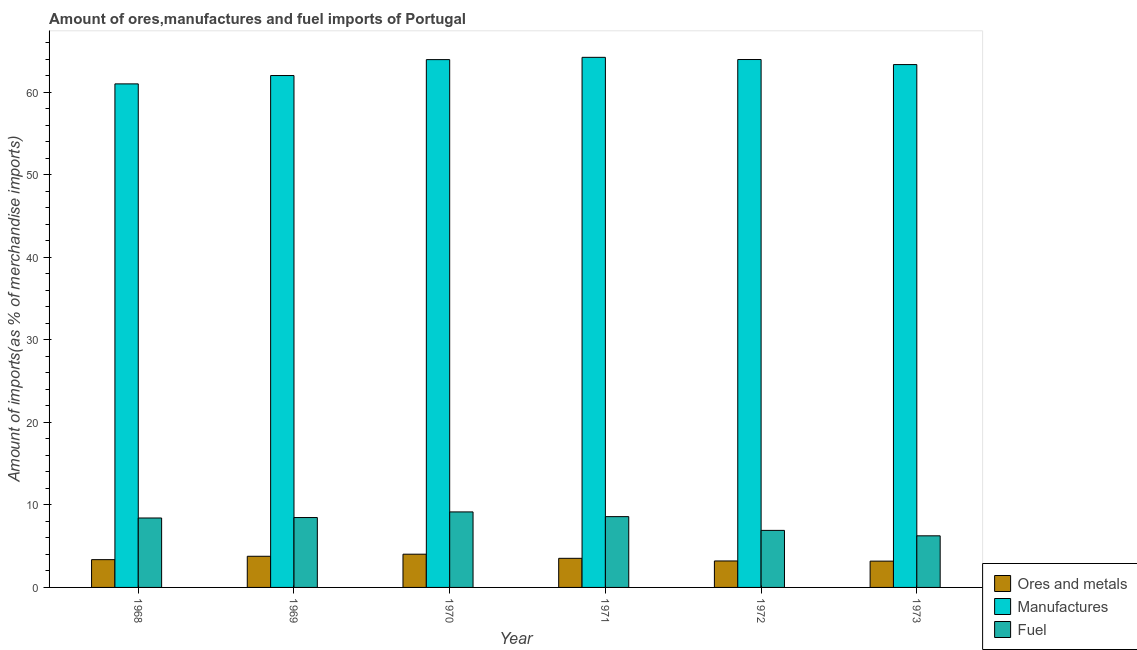How many different coloured bars are there?
Your response must be concise. 3. Are the number of bars on each tick of the X-axis equal?
Your answer should be very brief. Yes. How many bars are there on the 5th tick from the left?
Your response must be concise. 3. What is the label of the 6th group of bars from the left?
Make the answer very short. 1973. What is the percentage of fuel imports in 1970?
Keep it short and to the point. 9.15. Across all years, what is the maximum percentage of fuel imports?
Provide a succinct answer. 9.15. Across all years, what is the minimum percentage of ores and metals imports?
Your answer should be very brief. 3.18. In which year was the percentage of ores and metals imports minimum?
Offer a terse response. 1973. What is the total percentage of manufactures imports in the graph?
Offer a terse response. 378.41. What is the difference between the percentage of fuel imports in 1968 and that in 1972?
Your answer should be very brief. 1.5. What is the difference between the percentage of ores and metals imports in 1969 and the percentage of fuel imports in 1971?
Your response must be concise. 0.25. What is the average percentage of fuel imports per year?
Your response must be concise. 7.96. What is the ratio of the percentage of fuel imports in 1970 to that in 1971?
Your answer should be compact. 1.07. Is the percentage of fuel imports in 1969 less than that in 1971?
Make the answer very short. Yes. Is the difference between the percentage of manufactures imports in 1970 and 1971 greater than the difference between the percentage of ores and metals imports in 1970 and 1971?
Provide a short and direct response. No. What is the difference between the highest and the second highest percentage of ores and metals imports?
Ensure brevity in your answer.  0.25. What is the difference between the highest and the lowest percentage of fuel imports?
Your answer should be compact. 2.9. In how many years, is the percentage of ores and metals imports greater than the average percentage of ores and metals imports taken over all years?
Your answer should be compact. 3. What does the 1st bar from the left in 1969 represents?
Your answer should be compact. Ores and metals. What does the 1st bar from the right in 1971 represents?
Keep it short and to the point. Fuel. How many bars are there?
Provide a short and direct response. 18. Are all the bars in the graph horizontal?
Keep it short and to the point. No. How many years are there in the graph?
Ensure brevity in your answer.  6. What is the difference between two consecutive major ticks on the Y-axis?
Provide a short and direct response. 10. Are the values on the major ticks of Y-axis written in scientific E-notation?
Give a very brief answer. No. Where does the legend appear in the graph?
Offer a very short reply. Bottom right. How are the legend labels stacked?
Offer a terse response. Vertical. What is the title of the graph?
Ensure brevity in your answer.  Amount of ores,manufactures and fuel imports of Portugal. What is the label or title of the X-axis?
Give a very brief answer. Year. What is the label or title of the Y-axis?
Keep it short and to the point. Amount of imports(as % of merchandise imports). What is the Amount of imports(as % of merchandise imports) of Ores and metals in 1968?
Your answer should be compact. 3.37. What is the Amount of imports(as % of merchandise imports) of Manufactures in 1968?
Offer a very short reply. 60.99. What is the Amount of imports(as % of merchandise imports) in Fuel in 1968?
Keep it short and to the point. 8.41. What is the Amount of imports(as % of merchandise imports) in Ores and metals in 1969?
Ensure brevity in your answer.  3.77. What is the Amount of imports(as % of merchandise imports) in Manufactures in 1969?
Offer a very short reply. 62. What is the Amount of imports(as % of merchandise imports) in Fuel in 1969?
Your answer should be compact. 8.47. What is the Amount of imports(as % of merchandise imports) in Ores and metals in 1970?
Offer a terse response. 4.02. What is the Amount of imports(as % of merchandise imports) of Manufactures in 1970?
Offer a terse response. 63.93. What is the Amount of imports(as % of merchandise imports) of Fuel in 1970?
Your answer should be very brief. 9.15. What is the Amount of imports(as % of merchandise imports) of Ores and metals in 1971?
Keep it short and to the point. 3.53. What is the Amount of imports(as % of merchandise imports) of Manufactures in 1971?
Your answer should be compact. 64.21. What is the Amount of imports(as % of merchandise imports) in Fuel in 1971?
Make the answer very short. 8.57. What is the Amount of imports(as % of merchandise imports) of Ores and metals in 1972?
Give a very brief answer. 3.21. What is the Amount of imports(as % of merchandise imports) in Manufactures in 1972?
Provide a succinct answer. 63.94. What is the Amount of imports(as % of merchandise imports) in Fuel in 1972?
Your answer should be very brief. 6.91. What is the Amount of imports(as % of merchandise imports) in Ores and metals in 1973?
Keep it short and to the point. 3.18. What is the Amount of imports(as % of merchandise imports) of Manufactures in 1973?
Offer a terse response. 63.33. What is the Amount of imports(as % of merchandise imports) of Fuel in 1973?
Offer a terse response. 6.25. Across all years, what is the maximum Amount of imports(as % of merchandise imports) of Ores and metals?
Offer a very short reply. 4.02. Across all years, what is the maximum Amount of imports(as % of merchandise imports) in Manufactures?
Make the answer very short. 64.21. Across all years, what is the maximum Amount of imports(as % of merchandise imports) in Fuel?
Your answer should be compact. 9.15. Across all years, what is the minimum Amount of imports(as % of merchandise imports) of Ores and metals?
Make the answer very short. 3.18. Across all years, what is the minimum Amount of imports(as % of merchandise imports) of Manufactures?
Ensure brevity in your answer.  60.99. Across all years, what is the minimum Amount of imports(as % of merchandise imports) in Fuel?
Provide a short and direct response. 6.25. What is the total Amount of imports(as % of merchandise imports) in Ores and metals in the graph?
Offer a terse response. 21.08. What is the total Amount of imports(as % of merchandise imports) in Manufactures in the graph?
Give a very brief answer. 378.41. What is the total Amount of imports(as % of merchandise imports) in Fuel in the graph?
Make the answer very short. 47.76. What is the difference between the Amount of imports(as % of merchandise imports) in Ores and metals in 1968 and that in 1969?
Your answer should be compact. -0.41. What is the difference between the Amount of imports(as % of merchandise imports) of Manufactures in 1968 and that in 1969?
Provide a succinct answer. -1.01. What is the difference between the Amount of imports(as % of merchandise imports) of Fuel in 1968 and that in 1969?
Make the answer very short. -0.06. What is the difference between the Amount of imports(as % of merchandise imports) in Ores and metals in 1968 and that in 1970?
Give a very brief answer. -0.66. What is the difference between the Amount of imports(as % of merchandise imports) of Manufactures in 1968 and that in 1970?
Your answer should be compact. -2.94. What is the difference between the Amount of imports(as % of merchandise imports) of Fuel in 1968 and that in 1970?
Provide a succinct answer. -0.74. What is the difference between the Amount of imports(as % of merchandise imports) of Ores and metals in 1968 and that in 1971?
Your answer should be compact. -0.16. What is the difference between the Amount of imports(as % of merchandise imports) of Manufactures in 1968 and that in 1971?
Your answer should be very brief. -3.22. What is the difference between the Amount of imports(as % of merchandise imports) in Fuel in 1968 and that in 1971?
Ensure brevity in your answer.  -0.17. What is the difference between the Amount of imports(as % of merchandise imports) of Ores and metals in 1968 and that in 1972?
Give a very brief answer. 0.16. What is the difference between the Amount of imports(as % of merchandise imports) of Manufactures in 1968 and that in 1972?
Keep it short and to the point. -2.95. What is the difference between the Amount of imports(as % of merchandise imports) of Fuel in 1968 and that in 1972?
Provide a short and direct response. 1.5. What is the difference between the Amount of imports(as % of merchandise imports) in Ores and metals in 1968 and that in 1973?
Keep it short and to the point. 0.18. What is the difference between the Amount of imports(as % of merchandise imports) in Manufactures in 1968 and that in 1973?
Provide a succinct answer. -2.34. What is the difference between the Amount of imports(as % of merchandise imports) of Fuel in 1968 and that in 1973?
Offer a very short reply. 2.16. What is the difference between the Amount of imports(as % of merchandise imports) in Ores and metals in 1969 and that in 1970?
Offer a terse response. -0.25. What is the difference between the Amount of imports(as % of merchandise imports) of Manufactures in 1969 and that in 1970?
Your response must be concise. -1.93. What is the difference between the Amount of imports(as % of merchandise imports) of Fuel in 1969 and that in 1970?
Your answer should be compact. -0.68. What is the difference between the Amount of imports(as % of merchandise imports) in Ores and metals in 1969 and that in 1971?
Give a very brief answer. 0.25. What is the difference between the Amount of imports(as % of merchandise imports) of Manufactures in 1969 and that in 1971?
Your response must be concise. -2.2. What is the difference between the Amount of imports(as % of merchandise imports) in Fuel in 1969 and that in 1971?
Ensure brevity in your answer.  -0.11. What is the difference between the Amount of imports(as % of merchandise imports) of Ores and metals in 1969 and that in 1972?
Your response must be concise. 0.57. What is the difference between the Amount of imports(as % of merchandise imports) of Manufactures in 1969 and that in 1972?
Make the answer very short. -1.94. What is the difference between the Amount of imports(as % of merchandise imports) in Fuel in 1969 and that in 1972?
Keep it short and to the point. 1.56. What is the difference between the Amount of imports(as % of merchandise imports) of Ores and metals in 1969 and that in 1973?
Give a very brief answer. 0.59. What is the difference between the Amount of imports(as % of merchandise imports) of Manufactures in 1969 and that in 1973?
Provide a succinct answer. -1.33. What is the difference between the Amount of imports(as % of merchandise imports) in Fuel in 1969 and that in 1973?
Provide a short and direct response. 2.22. What is the difference between the Amount of imports(as % of merchandise imports) of Ores and metals in 1970 and that in 1971?
Offer a terse response. 0.5. What is the difference between the Amount of imports(as % of merchandise imports) of Manufactures in 1970 and that in 1971?
Make the answer very short. -0.28. What is the difference between the Amount of imports(as % of merchandise imports) of Fuel in 1970 and that in 1971?
Your response must be concise. 0.57. What is the difference between the Amount of imports(as % of merchandise imports) of Ores and metals in 1970 and that in 1972?
Offer a very short reply. 0.82. What is the difference between the Amount of imports(as % of merchandise imports) of Manufactures in 1970 and that in 1972?
Make the answer very short. -0.01. What is the difference between the Amount of imports(as % of merchandise imports) of Fuel in 1970 and that in 1972?
Give a very brief answer. 2.24. What is the difference between the Amount of imports(as % of merchandise imports) of Ores and metals in 1970 and that in 1973?
Ensure brevity in your answer.  0.84. What is the difference between the Amount of imports(as % of merchandise imports) in Manufactures in 1970 and that in 1973?
Keep it short and to the point. 0.6. What is the difference between the Amount of imports(as % of merchandise imports) in Fuel in 1970 and that in 1973?
Ensure brevity in your answer.  2.9. What is the difference between the Amount of imports(as % of merchandise imports) of Ores and metals in 1971 and that in 1972?
Keep it short and to the point. 0.32. What is the difference between the Amount of imports(as % of merchandise imports) of Manufactures in 1971 and that in 1972?
Give a very brief answer. 0.27. What is the difference between the Amount of imports(as % of merchandise imports) in Fuel in 1971 and that in 1972?
Keep it short and to the point. 1.67. What is the difference between the Amount of imports(as % of merchandise imports) of Ores and metals in 1971 and that in 1973?
Keep it short and to the point. 0.34. What is the difference between the Amount of imports(as % of merchandise imports) in Manufactures in 1971 and that in 1973?
Offer a terse response. 0.88. What is the difference between the Amount of imports(as % of merchandise imports) of Fuel in 1971 and that in 1973?
Your response must be concise. 2.32. What is the difference between the Amount of imports(as % of merchandise imports) in Ores and metals in 1972 and that in 1973?
Provide a succinct answer. 0.02. What is the difference between the Amount of imports(as % of merchandise imports) of Manufactures in 1972 and that in 1973?
Give a very brief answer. 0.61. What is the difference between the Amount of imports(as % of merchandise imports) in Fuel in 1972 and that in 1973?
Keep it short and to the point. 0.66. What is the difference between the Amount of imports(as % of merchandise imports) in Ores and metals in 1968 and the Amount of imports(as % of merchandise imports) in Manufactures in 1969?
Provide a short and direct response. -58.64. What is the difference between the Amount of imports(as % of merchandise imports) in Ores and metals in 1968 and the Amount of imports(as % of merchandise imports) in Fuel in 1969?
Your response must be concise. -5.1. What is the difference between the Amount of imports(as % of merchandise imports) in Manufactures in 1968 and the Amount of imports(as % of merchandise imports) in Fuel in 1969?
Keep it short and to the point. 52.53. What is the difference between the Amount of imports(as % of merchandise imports) in Ores and metals in 1968 and the Amount of imports(as % of merchandise imports) in Manufactures in 1970?
Make the answer very short. -60.57. What is the difference between the Amount of imports(as % of merchandise imports) in Ores and metals in 1968 and the Amount of imports(as % of merchandise imports) in Fuel in 1970?
Your answer should be compact. -5.78. What is the difference between the Amount of imports(as % of merchandise imports) in Manufactures in 1968 and the Amount of imports(as % of merchandise imports) in Fuel in 1970?
Provide a succinct answer. 51.85. What is the difference between the Amount of imports(as % of merchandise imports) of Ores and metals in 1968 and the Amount of imports(as % of merchandise imports) of Manufactures in 1971?
Make the answer very short. -60.84. What is the difference between the Amount of imports(as % of merchandise imports) in Ores and metals in 1968 and the Amount of imports(as % of merchandise imports) in Fuel in 1971?
Offer a very short reply. -5.21. What is the difference between the Amount of imports(as % of merchandise imports) of Manufactures in 1968 and the Amount of imports(as % of merchandise imports) of Fuel in 1971?
Your answer should be compact. 52.42. What is the difference between the Amount of imports(as % of merchandise imports) of Ores and metals in 1968 and the Amount of imports(as % of merchandise imports) of Manufactures in 1972?
Offer a terse response. -60.58. What is the difference between the Amount of imports(as % of merchandise imports) of Ores and metals in 1968 and the Amount of imports(as % of merchandise imports) of Fuel in 1972?
Give a very brief answer. -3.54. What is the difference between the Amount of imports(as % of merchandise imports) of Manufactures in 1968 and the Amount of imports(as % of merchandise imports) of Fuel in 1972?
Provide a short and direct response. 54.08. What is the difference between the Amount of imports(as % of merchandise imports) of Ores and metals in 1968 and the Amount of imports(as % of merchandise imports) of Manufactures in 1973?
Provide a succinct answer. -59.96. What is the difference between the Amount of imports(as % of merchandise imports) of Ores and metals in 1968 and the Amount of imports(as % of merchandise imports) of Fuel in 1973?
Make the answer very short. -2.88. What is the difference between the Amount of imports(as % of merchandise imports) in Manufactures in 1968 and the Amount of imports(as % of merchandise imports) in Fuel in 1973?
Ensure brevity in your answer.  54.74. What is the difference between the Amount of imports(as % of merchandise imports) in Ores and metals in 1969 and the Amount of imports(as % of merchandise imports) in Manufactures in 1970?
Offer a terse response. -60.16. What is the difference between the Amount of imports(as % of merchandise imports) in Ores and metals in 1969 and the Amount of imports(as % of merchandise imports) in Fuel in 1970?
Your response must be concise. -5.37. What is the difference between the Amount of imports(as % of merchandise imports) in Manufactures in 1969 and the Amount of imports(as % of merchandise imports) in Fuel in 1970?
Provide a short and direct response. 52.86. What is the difference between the Amount of imports(as % of merchandise imports) of Ores and metals in 1969 and the Amount of imports(as % of merchandise imports) of Manufactures in 1971?
Your response must be concise. -60.44. What is the difference between the Amount of imports(as % of merchandise imports) of Ores and metals in 1969 and the Amount of imports(as % of merchandise imports) of Fuel in 1971?
Your answer should be compact. -4.8. What is the difference between the Amount of imports(as % of merchandise imports) in Manufactures in 1969 and the Amount of imports(as % of merchandise imports) in Fuel in 1971?
Your answer should be very brief. 53.43. What is the difference between the Amount of imports(as % of merchandise imports) in Ores and metals in 1969 and the Amount of imports(as % of merchandise imports) in Manufactures in 1972?
Your answer should be compact. -60.17. What is the difference between the Amount of imports(as % of merchandise imports) in Ores and metals in 1969 and the Amount of imports(as % of merchandise imports) in Fuel in 1972?
Make the answer very short. -3.14. What is the difference between the Amount of imports(as % of merchandise imports) of Manufactures in 1969 and the Amount of imports(as % of merchandise imports) of Fuel in 1972?
Ensure brevity in your answer.  55.09. What is the difference between the Amount of imports(as % of merchandise imports) in Ores and metals in 1969 and the Amount of imports(as % of merchandise imports) in Manufactures in 1973?
Provide a short and direct response. -59.56. What is the difference between the Amount of imports(as % of merchandise imports) of Ores and metals in 1969 and the Amount of imports(as % of merchandise imports) of Fuel in 1973?
Provide a succinct answer. -2.48. What is the difference between the Amount of imports(as % of merchandise imports) of Manufactures in 1969 and the Amount of imports(as % of merchandise imports) of Fuel in 1973?
Offer a terse response. 55.75. What is the difference between the Amount of imports(as % of merchandise imports) in Ores and metals in 1970 and the Amount of imports(as % of merchandise imports) in Manufactures in 1971?
Offer a very short reply. -60.18. What is the difference between the Amount of imports(as % of merchandise imports) in Ores and metals in 1970 and the Amount of imports(as % of merchandise imports) in Fuel in 1971?
Keep it short and to the point. -4.55. What is the difference between the Amount of imports(as % of merchandise imports) of Manufactures in 1970 and the Amount of imports(as % of merchandise imports) of Fuel in 1971?
Your response must be concise. 55.36. What is the difference between the Amount of imports(as % of merchandise imports) of Ores and metals in 1970 and the Amount of imports(as % of merchandise imports) of Manufactures in 1972?
Keep it short and to the point. -59.92. What is the difference between the Amount of imports(as % of merchandise imports) in Ores and metals in 1970 and the Amount of imports(as % of merchandise imports) in Fuel in 1972?
Give a very brief answer. -2.89. What is the difference between the Amount of imports(as % of merchandise imports) of Manufactures in 1970 and the Amount of imports(as % of merchandise imports) of Fuel in 1972?
Offer a very short reply. 57.02. What is the difference between the Amount of imports(as % of merchandise imports) in Ores and metals in 1970 and the Amount of imports(as % of merchandise imports) in Manufactures in 1973?
Provide a short and direct response. -59.31. What is the difference between the Amount of imports(as % of merchandise imports) of Ores and metals in 1970 and the Amount of imports(as % of merchandise imports) of Fuel in 1973?
Keep it short and to the point. -2.23. What is the difference between the Amount of imports(as % of merchandise imports) in Manufactures in 1970 and the Amount of imports(as % of merchandise imports) in Fuel in 1973?
Provide a short and direct response. 57.68. What is the difference between the Amount of imports(as % of merchandise imports) in Ores and metals in 1971 and the Amount of imports(as % of merchandise imports) in Manufactures in 1972?
Your response must be concise. -60.42. What is the difference between the Amount of imports(as % of merchandise imports) in Ores and metals in 1971 and the Amount of imports(as % of merchandise imports) in Fuel in 1972?
Provide a short and direct response. -3.38. What is the difference between the Amount of imports(as % of merchandise imports) of Manufactures in 1971 and the Amount of imports(as % of merchandise imports) of Fuel in 1972?
Your response must be concise. 57.3. What is the difference between the Amount of imports(as % of merchandise imports) in Ores and metals in 1971 and the Amount of imports(as % of merchandise imports) in Manufactures in 1973?
Offer a very short reply. -59.8. What is the difference between the Amount of imports(as % of merchandise imports) of Ores and metals in 1971 and the Amount of imports(as % of merchandise imports) of Fuel in 1973?
Provide a short and direct response. -2.72. What is the difference between the Amount of imports(as % of merchandise imports) in Manufactures in 1971 and the Amount of imports(as % of merchandise imports) in Fuel in 1973?
Your response must be concise. 57.96. What is the difference between the Amount of imports(as % of merchandise imports) of Ores and metals in 1972 and the Amount of imports(as % of merchandise imports) of Manufactures in 1973?
Provide a succinct answer. -60.12. What is the difference between the Amount of imports(as % of merchandise imports) in Ores and metals in 1972 and the Amount of imports(as % of merchandise imports) in Fuel in 1973?
Make the answer very short. -3.04. What is the difference between the Amount of imports(as % of merchandise imports) of Manufactures in 1972 and the Amount of imports(as % of merchandise imports) of Fuel in 1973?
Ensure brevity in your answer.  57.69. What is the average Amount of imports(as % of merchandise imports) in Ores and metals per year?
Your answer should be compact. 3.51. What is the average Amount of imports(as % of merchandise imports) in Manufactures per year?
Offer a very short reply. 63.07. What is the average Amount of imports(as % of merchandise imports) of Fuel per year?
Offer a very short reply. 7.96. In the year 1968, what is the difference between the Amount of imports(as % of merchandise imports) in Ores and metals and Amount of imports(as % of merchandise imports) in Manufactures?
Offer a terse response. -57.63. In the year 1968, what is the difference between the Amount of imports(as % of merchandise imports) in Ores and metals and Amount of imports(as % of merchandise imports) in Fuel?
Ensure brevity in your answer.  -5.04. In the year 1968, what is the difference between the Amount of imports(as % of merchandise imports) of Manufactures and Amount of imports(as % of merchandise imports) of Fuel?
Your answer should be very brief. 52.58. In the year 1969, what is the difference between the Amount of imports(as % of merchandise imports) in Ores and metals and Amount of imports(as % of merchandise imports) in Manufactures?
Keep it short and to the point. -58.23. In the year 1969, what is the difference between the Amount of imports(as % of merchandise imports) of Ores and metals and Amount of imports(as % of merchandise imports) of Fuel?
Provide a succinct answer. -4.69. In the year 1969, what is the difference between the Amount of imports(as % of merchandise imports) in Manufactures and Amount of imports(as % of merchandise imports) in Fuel?
Your answer should be very brief. 53.54. In the year 1970, what is the difference between the Amount of imports(as % of merchandise imports) of Ores and metals and Amount of imports(as % of merchandise imports) of Manufactures?
Offer a very short reply. -59.91. In the year 1970, what is the difference between the Amount of imports(as % of merchandise imports) in Ores and metals and Amount of imports(as % of merchandise imports) in Fuel?
Make the answer very short. -5.12. In the year 1970, what is the difference between the Amount of imports(as % of merchandise imports) in Manufactures and Amount of imports(as % of merchandise imports) in Fuel?
Keep it short and to the point. 54.79. In the year 1971, what is the difference between the Amount of imports(as % of merchandise imports) in Ores and metals and Amount of imports(as % of merchandise imports) in Manufactures?
Keep it short and to the point. -60.68. In the year 1971, what is the difference between the Amount of imports(as % of merchandise imports) of Ores and metals and Amount of imports(as % of merchandise imports) of Fuel?
Offer a terse response. -5.05. In the year 1971, what is the difference between the Amount of imports(as % of merchandise imports) in Manufactures and Amount of imports(as % of merchandise imports) in Fuel?
Make the answer very short. 55.63. In the year 1972, what is the difference between the Amount of imports(as % of merchandise imports) of Ores and metals and Amount of imports(as % of merchandise imports) of Manufactures?
Offer a very short reply. -60.74. In the year 1972, what is the difference between the Amount of imports(as % of merchandise imports) in Ores and metals and Amount of imports(as % of merchandise imports) in Fuel?
Provide a short and direct response. -3.7. In the year 1972, what is the difference between the Amount of imports(as % of merchandise imports) of Manufactures and Amount of imports(as % of merchandise imports) of Fuel?
Your response must be concise. 57.03. In the year 1973, what is the difference between the Amount of imports(as % of merchandise imports) in Ores and metals and Amount of imports(as % of merchandise imports) in Manufactures?
Offer a terse response. -60.15. In the year 1973, what is the difference between the Amount of imports(as % of merchandise imports) in Ores and metals and Amount of imports(as % of merchandise imports) in Fuel?
Provide a succinct answer. -3.07. In the year 1973, what is the difference between the Amount of imports(as % of merchandise imports) in Manufactures and Amount of imports(as % of merchandise imports) in Fuel?
Keep it short and to the point. 57.08. What is the ratio of the Amount of imports(as % of merchandise imports) of Ores and metals in 1968 to that in 1969?
Offer a terse response. 0.89. What is the ratio of the Amount of imports(as % of merchandise imports) in Manufactures in 1968 to that in 1969?
Your answer should be compact. 0.98. What is the ratio of the Amount of imports(as % of merchandise imports) in Fuel in 1968 to that in 1969?
Offer a terse response. 0.99. What is the ratio of the Amount of imports(as % of merchandise imports) in Ores and metals in 1968 to that in 1970?
Give a very brief answer. 0.84. What is the ratio of the Amount of imports(as % of merchandise imports) in Manufactures in 1968 to that in 1970?
Provide a succinct answer. 0.95. What is the ratio of the Amount of imports(as % of merchandise imports) in Fuel in 1968 to that in 1970?
Your answer should be compact. 0.92. What is the ratio of the Amount of imports(as % of merchandise imports) in Ores and metals in 1968 to that in 1971?
Ensure brevity in your answer.  0.95. What is the ratio of the Amount of imports(as % of merchandise imports) in Manufactures in 1968 to that in 1971?
Give a very brief answer. 0.95. What is the ratio of the Amount of imports(as % of merchandise imports) of Fuel in 1968 to that in 1971?
Your response must be concise. 0.98. What is the ratio of the Amount of imports(as % of merchandise imports) of Ores and metals in 1968 to that in 1972?
Your response must be concise. 1.05. What is the ratio of the Amount of imports(as % of merchandise imports) of Manufactures in 1968 to that in 1972?
Offer a very short reply. 0.95. What is the ratio of the Amount of imports(as % of merchandise imports) of Fuel in 1968 to that in 1972?
Give a very brief answer. 1.22. What is the ratio of the Amount of imports(as % of merchandise imports) of Ores and metals in 1968 to that in 1973?
Keep it short and to the point. 1.06. What is the ratio of the Amount of imports(as % of merchandise imports) of Manufactures in 1968 to that in 1973?
Provide a short and direct response. 0.96. What is the ratio of the Amount of imports(as % of merchandise imports) of Fuel in 1968 to that in 1973?
Your response must be concise. 1.35. What is the ratio of the Amount of imports(as % of merchandise imports) in Ores and metals in 1969 to that in 1970?
Offer a terse response. 0.94. What is the ratio of the Amount of imports(as % of merchandise imports) of Manufactures in 1969 to that in 1970?
Make the answer very short. 0.97. What is the ratio of the Amount of imports(as % of merchandise imports) of Fuel in 1969 to that in 1970?
Ensure brevity in your answer.  0.93. What is the ratio of the Amount of imports(as % of merchandise imports) in Ores and metals in 1969 to that in 1971?
Give a very brief answer. 1.07. What is the ratio of the Amount of imports(as % of merchandise imports) of Manufactures in 1969 to that in 1971?
Offer a terse response. 0.97. What is the ratio of the Amount of imports(as % of merchandise imports) of Fuel in 1969 to that in 1971?
Your answer should be very brief. 0.99. What is the ratio of the Amount of imports(as % of merchandise imports) of Ores and metals in 1969 to that in 1972?
Offer a terse response. 1.18. What is the ratio of the Amount of imports(as % of merchandise imports) of Manufactures in 1969 to that in 1972?
Your response must be concise. 0.97. What is the ratio of the Amount of imports(as % of merchandise imports) in Fuel in 1969 to that in 1972?
Give a very brief answer. 1.23. What is the ratio of the Amount of imports(as % of merchandise imports) of Ores and metals in 1969 to that in 1973?
Keep it short and to the point. 1.19. What is the ratio of the Amount of imports(as % of merchandise imports) of Manufactures in 1969 to that in 1973?
Provide a short and direct response. 0.98. What is the ratio of the Amount of imports(as % of merchandise imports) in Fuel in 1969 to that in 1973?
Ensure brevity in your answer.  1.35. What is the ratio of the Amount of imports(as % of merchandise imports) in Ores and metals in 1970 to that in 1971?
Make the answer very short. 1.14. What is the ratio of the Amount of imports(as % of merchandise imports) of Manufactures in 1970 to that in 1971?
Your answer should be very brief. 1. What is the ratio of the Amount of imports(as % of merchandise imports) in Fuel in 1970 to that in 1971?
Keep it short and to the point. 1.07. What is the ratio of the Amount of imports(as % of merchandise imports) in Ores and metals in 1970 to that in 1972?
Your response must be concise. 1.26. What is the ratio of the Amount of imports(as % of merchandise imports) of Fuel in 1970 to that in 1972?
Your response must be concise. 1.32. What is the ratio of the Amount of imports(as % of merchandise imports) in Ores and metals in 1970 to that in 1973?
Ensure brevity in your answer.  1.26. What is the ratio of the Amount of imports(as % of merchandise imports) of Manufactures in 1970 to that in 1973?
Your answer should be compact. 1.01. What is the ratio of the Amount of imports(as % of merchandise imports) in Fuel in 1970 to that in 1973?
Keep it short and to the point. 1.46. What is the ratio of the Amount of imports(as % of merchandise imports) in Ores and metals in 1971 to that in 1972?
Ensure brevity in your answer.  1.1. What is the ratio of the Amount of imports(as % of merchandise imports) in Fuel in 1971 to that in 1972?
Your response must be concise. 1.24. What is the ratio of the Amount of imports(as % of merchandise imports) of Ores and metals in 1971 to that in 1973?
Keep it short and to the point. 1.11. What is the ratio of the Amount of imports(as % of merchandise imports) in Manufactures in 1971 to that in 1973?
Ensure brevity in your answer.  1.01. What is the ratio of the Amount of imports(as % of merchandise imports) of Fuel in 1971 to that in 1973?
Make the answer very short. 1.37. What is the ratio of the Amount of imports(as % of merchandise imports) in Ores and metals in 1972 to that in 1973?
Your response must be concise. 1.01. What is the ratio of the Amount of imports(as % of merchandise imports) of Manufactures in 1972 to that in 1973?
Provide a succinct answer. 1.01. What is the ratio of the Amount of imports(as % of merchandise imports) in Fuel in 1972 to that in 1973?
Offer a very short reply. 1.11. What is the difference between the highest and the second highest Amount of imports(as % of merchandise imports) in Ores and metals?
Make the answer very short. 0.25. What is the difference between the highest and the second highest Amount of imports(as % of merchandise imports) of Manufactures?
Ensure brevity in your answer.  0.27. What is the difference between the highest and the second highest Amount of imports(as % of merchandise imports) in Fuel?
Make the answer very short. 0.57. What is the difference between the highest and the lowest Amount of imports(as % of merchandise imports) of Ores and metals?
Offer a terse response. 0.84. What is the difference between the highest and the lowest Amount of imports(as % of merchandise imports) in Manufactures?
Give a very brief answer. 3.22. What is the difference between the highest and the lowest Amount of imports(as % of merchandise imports) of Fuel?
Offer a very short reply. 2.9. 